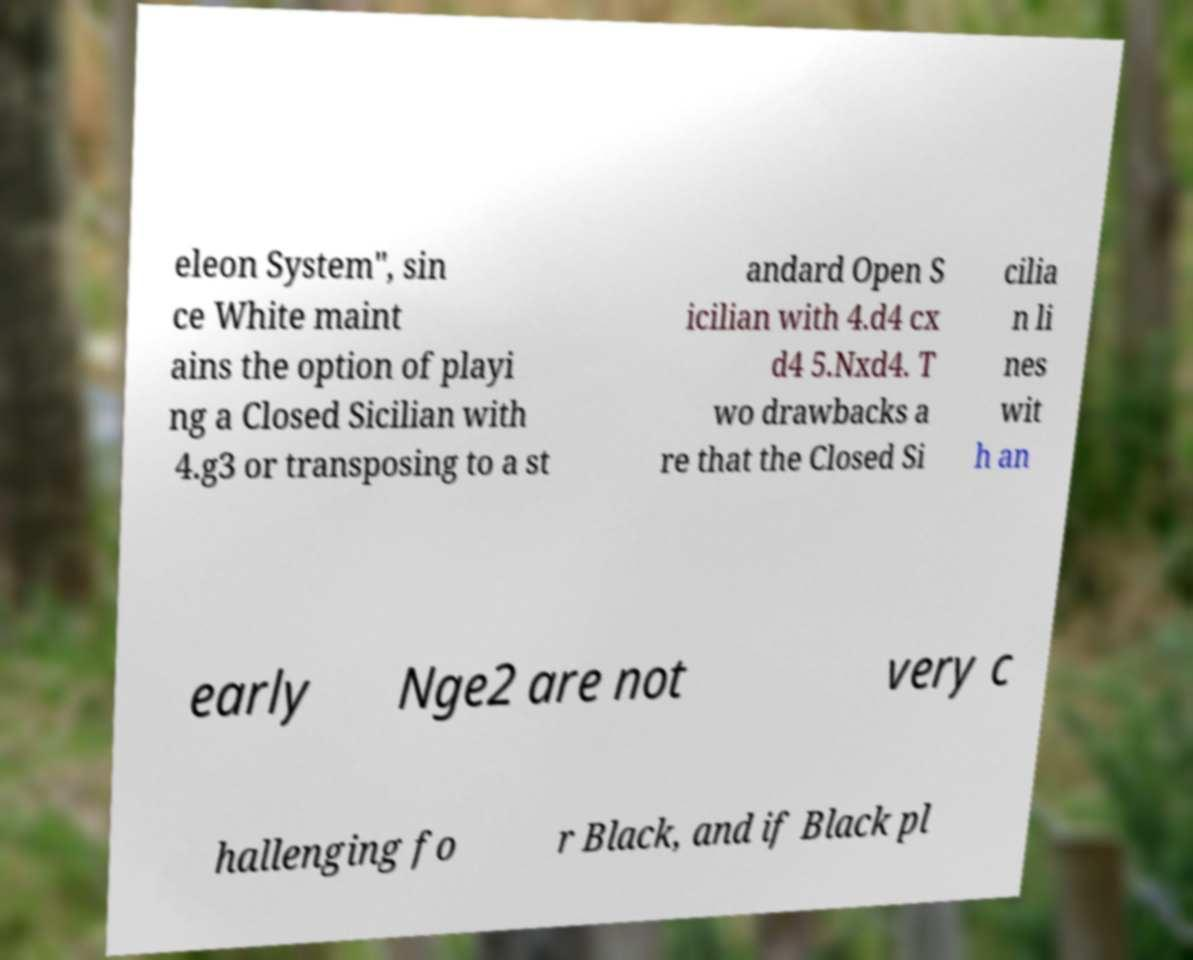Can you accurately transcribe the text from the provided image for me? eleon System", sin ce White maint ains the option of playi ng a Closed Sicilian with 4.g3 or transposing to a st andard Open S icilian with 4.d4 cx d4 5.Nxd4. T wo drawbacks a re that the Closed Si cilia n li nes wit h an early Nge2 are not very c hallenging fo r Black, and if Black pl 